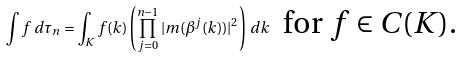Convert formula to latex. <formula><loc_0><loc_0><loc_500><loc_500>\int f \, d \tau _ { n } = \int _ { K } f ( k ) \left ( { \prod _ { j = 0 } ^ { n - 1 } | m ( \beta ^ { j } ( k ) ) | ^ { 2 } } \right ) \, d k \ \text { for $f\in C(K)$.}</formula> 